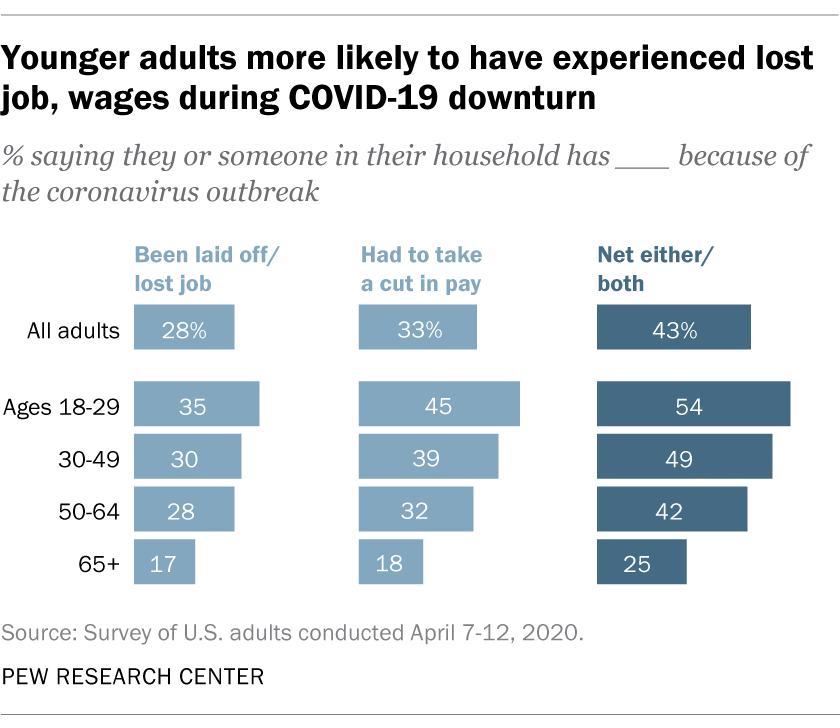Mention a couple of crucial points in this snapshot. The missing value in the sequence 28, 35, 30, 28, ... is 17. In the context of "Been laid off/lost job", the value of 28 would be increased to 2800. 